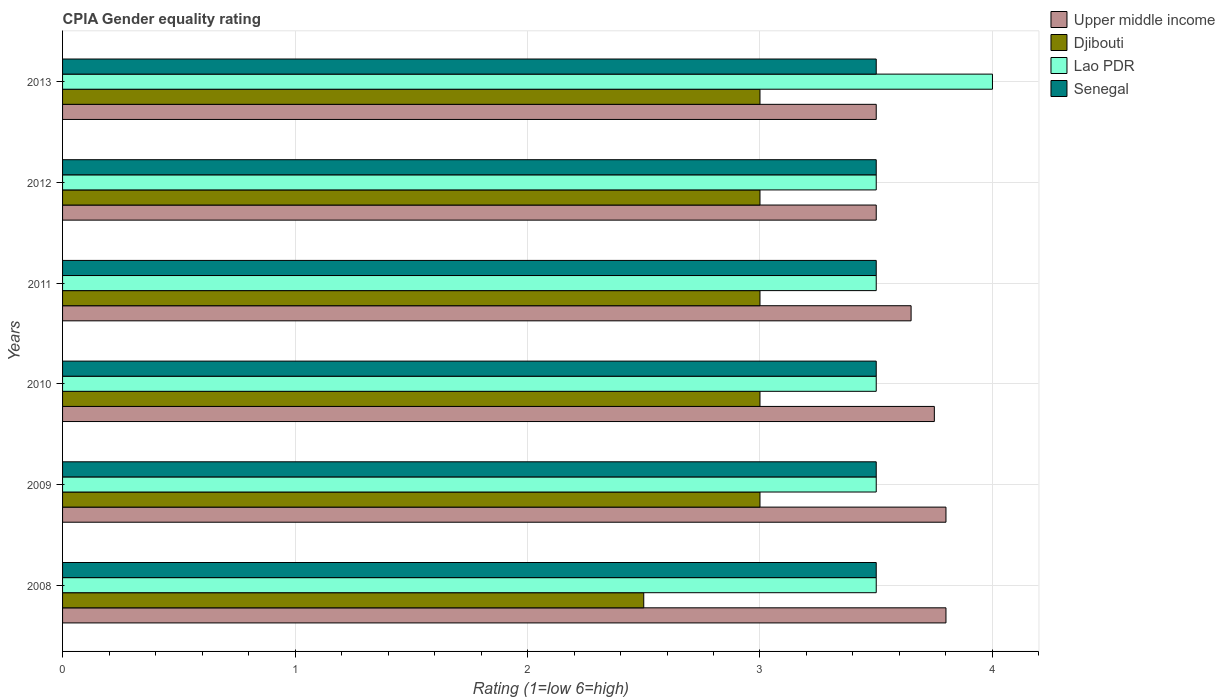How many different coloured bars are there?
Give a very brief answer. 4. Are the number of bars on each tick of the Y-axis equal?
Keep it short and to the point. Yes. How many bars are there on the 1st tick from the bottom?
Ensure brevity in your answer.  4. What is the label of the 1st group of bars from the top?
Give a very brief answer. 2013. In how many cases, is the number of bars for a given year not equal to the number of legend labels?
Offer a very short reply. 0. Across all years, what is the minimum CPIA rating in Lao PDR?
Provide a short and direct response. 3.5. In which year was the CPIA rating in Djibouti minimum?
Your answer should be very brief. 2008. What is the total CPIA rating in Djibouti in the graph?
Keep it short and to the point. 17.5. What is the difference between the CPIA rating in Upper middle income in 2011 and the CPIA rating in Senegal in 2008?
Keep it short and to the point. 0.15. What is the average CPIA rating in Djibouti per year?
Give a very brief answer. 2.92. What is the ratio of the CPIA rating in Upper middle income in 2008 to that in 2012?
Ensure brevity in your answer.  1.09. What is the difference between the highest and the lowest CPIA rating in Djibouti?
Your answer should be compact. 0.5. Is it the case that in every year, the sum of the CPIA rating in Senegal and CPIA rating in Lao PDR is greater than the sum of CPIA rating in Upper middle income and CPIA rating in Djibouti?
Your answer should be compact. No. What does the 2nd bar from the top in 2009 represents?
Provide a succinct answer. Lao PDR. What does the 4th bar from the bottom in 2013 represents?
Provide a short and direct response. Senegal. Is it the case that in every year, the sum of the CPIA rating in Senegal and CPIA rating in Djibouti is greater than the CPIA rating in Upper middle income?
Keep it short and to the point. Yes. How many bars are there?
Ensure brevity in your answer.  24. How many years are there in the graph?
Provide a succinct answer. 6. What is the title of the graph?
Give a very brief answer. CPIA Gender equality rating. What is the label or title of the X-axis?
Offer a very short reply. Rating (1=low 6=high). What is the Rating (1=low 6=high) of Upper middle income in 2008?
Ensure brevity in your answer.  3.8. What is the Rating (1=low 6=high) of Djibouti in 2008?
Ensure brevity in your answer.  2.5. What is the Rating (1=low 6=high) of Lao PDR in 2008?
Offer a terse response. 3.5. What is the Rating (1=low 6=high) in Senegal in 2008?
Your answer should be compact. 3.5. What is the Rating (1=low 6=high) in Upper middle income in 2009?
Offer a terse response. 3.8. What is the Rating (1=low 6=high) in Lao PDR in 2009?
Provide a succinct answer. 3.5. What is the Rating (1=low 6=high) of Upper middle income in 2010?
Give a very brief answer. 3.75. What is the Rating (1=low 6=high) in Upper middle income in 2011?
Provide a succinct answer. 3.65. What is the Rating (1=low 6=high) in Djibouti in 2011?
Give a very brief answer. 3. What is the Rating (1=low 6=high) in Lao PDR in 2011?
Provide a short and direct response. 3.5. What is the Rating (1=low 6=high) of Lao PDR in 2012?
Make the answer very short. 3.5. What is the Rating (1=low 6=high) of Upper middle income in 2013?
Give a very brief answer. 3.5. What is the Rating (1=low 6=high) in Lao PDR in 2013?
Offer a very short reply. 4. Across all years, what is the maximum Rating (1=low 6=high) of Lao PDR?
Provide a succinct answer. 4. Across all years, what is the maximum Rating (1=low 6=high) of Senegal?
Your answer should be very brief. 3.5. Across all years, what is the minimum Rating (1=low 6=high) of Upper middle income?
Your answer should be very brief. 3.5. Across all years, what is the minimum Rating (1=low 6=high) in Lao PDR?
Your answer should be very brief. 3.5. Across all years, what is the minimum Rating (1=low 6=high) in Senegal?
Provide a succinct answer. 3.5. What is the total Rating (1=low 6=high) of Upper middle income in the graph?
Provide a succinct answer. 22. What is the total Rating (1=low 6=high) of Djibouti in the graph?
Ensure brevity in your answer.  17.5. What is the total Rating (1=low 6=high) in Senegal in the graph?
Ensure brevity in your answer.  21. What is the difference between the Rating (1=low 6=high) in Upper middle income in 2008 and that in 2009?
Give a very brief answer. 0. What is the difference between the Rating (1=low 6=high) of Djibouti in 2008 and that in 2009?
Offer a terse response. -0.5. What is the difference between the Rating (1=low 6=high) in Lao PDR in 2008 and that in 2009?
Give a very brief answer. 0. What is the difference between the Rating (1=low 6=high) in Senegal in 2008 and that in 2009?
Your answer should be very brief. 0. What is the difference between the Rating (1=low 6=high) of Upper middle income in 2008 and that in 2010?
Offer a very short reply. 0.05. What is the difference between the Rating (1=low 6=high) of Senegal in 2008 and that in 2010?
Your response must be concise. 0. What is the difference between the Rating (1=low 6=high) in Djibouti in 2008 and that in 2011?
Ensure brevity in your answer.  -0.5. What is the difference between the Rating (1=low 6=high) of Upper middle income in 2008 and that in 2012?
Provide a short and direct response. 0.3. What is the difference between the Rating (1=low 6=high) in Lao PDR in 2008 and that in 2012?
Offer a terse response. 0. What is the difference between the Rating (1=low 6=high) of Upper middle income in 2008 and that in 2013?
Give a very brief answer. 0.3. What is the difference between the Rating (1=low 6=high) in Djibouti in 2008 and that in 2013?
Your response must be concise. -0.5. What is the difference between the Rating (1=low 6=high) of Lao PDR in 2008 and that in 2013?
Keep it short and to the point. -0.5. What is the difference between the Rating (1=low 6=high) of Senegal in 2008 and that in 2013?
Your answer should be very brief. 0. What is the difference between the Rating (1=low 6=high) in Lao PDR in 2009 and that in 2010?
Make the answer very short. 0. What is the difference between the Rating (1=low 6=high) of Lao PDR in 2009 and that in 2011?
Offer a terse response. 0. What is the difference between the Rating (1=low 6=high) of Senegal in 2009 and that in 2011?
Your answer should be very brief. 0. What is the difference between the Rating (1=low 6=high) in Upper middle income in 2009 and that in 2012?
Provide a short and direct response. 0.3. What is the difference between the Rating (1=low 6=high) in Lao PDR in 2009 and that in 2012?
Your answer should be compact. 0. What is the difference between the Rating (1=low 6=high) in Upper middle income in 2009 and that in 2013?
Your answer should be compact. 0.3. What is the difference between the Rating (1=low 6=high) of Djibouti in 2009 and that in 2013?
Make the answer very short. 0. What is the difference between the Rating (1=low 6=high) in Senegal in 2009 and that in 2013?
Provide a succinct answer. 0. What is the difference between the Rating (1=low 6=high) of Upper middle income in 2010 and that in 2011?
Provide a short and direct response. 0.1. What is the difference between the Rating (1=low 6=high) of Djibouti in 2010 and that in 2012?
Offer a terse response. 0. What is the difference between the Rating (1=low 6=high) in Lao PDR in 2010 and that in 2012?
Provide a succinct answer. 0. What is the difference between the Rating (1=low 6=high) in Lao PDR in 2010 and that in 2013?
Provide a short and direct response. -0.5. What is the difference between the Rating (1=low 6=high) of Upper middle income in 2011 and that in 2012?
Provide a succinct answer. 0.15. What is the difference between the Rating (1=low 6=high) of Lao PDR in 2011 and that in 2012?
Ensure brevity in your answer.  0. What is the difference between the Rating (1=low 6=high) of Senegal in 2011 and that in 2012?
Provide a short and direct response. 0. What is the difference between the Rating (1=low 6=high) of Upper middle income in 2011 and that in 2013?
Provide a succinct answer. 0.15. What is the difference between the Rating (1=low 6=high) in Lao PDR in 2012 and that in 2013?
Give a very brief answer. -0.5. What is the difference between the Rating (1=low 6=high) in Upper middle income in 2008 and the Rating (1=low 6=high) in Lao PDR in 2009?
Offer a very short reply. 0.3. What is the difference between the Rating (1=low 6=high) of Djibouti in 2008 and the Rating (1=low 6=high) of Lao PDR in 2009?
Provide a succinct answer. -1. What is the difference between the Rating (1=low 6=high) of Upper middle income in 2008 and the Rating (1=low 6=high) of Djibouti in 2010?
Provide a succinct answer. 0.8. What is the difference between the Rating (1=low 6=high) of Djibouti in 2008 and the Rating (1=low 6=high) of Lao PDR in 2010?
Offer a terse response. -1. What is the difference between the Rating (1=low 6=high) in Djibouti in 2008 and the Rating (1=low 6=high) in Senegal in 2010?
Your answer should be very brief. -1. What is the difference between the Rating (1=low 6=high) in Upper middle income in 2008 and the Rating (1=low 6=high) in Djibouti in 2011?
Provide a short and direct response. 0.8. What is the difference between the Rating (1=low 6=high) of Upper middle income in 2008 and the Rating (1=low 6=high) of Lao PDR in 2011?
Your answer should be compact. 0.3. What is the difference between the Rating (1=low 6=high) of Upper middle income in 2008 and the Rating (1=low 6=high) of Senegal in 2011?
Ensure brevity in your answer.  0.3. What is the difference between the Rating (1=low 6=high) of Lao PDR in 2008 and the Rating (1=low 6=high) of Senegal in 2011?
Give a very brief answer. 0. What is the difference between the Rating (1=low 6=high) in Upper middle income in 2008 and the Rating (1=low 6=high) in Senegal in 2012?
Provide a short and direct response. 0.3. What is the difference between the Rating (1=low 6=high) in Djibouti in 2008 and the Rating (1=low 6=high) in Senegal in 2012?
Your answer should be compact. -1. What is the difference between the Rating (1=low 6=high) of Upper middle income in 2008 and the Rating (1=low 6=high) of Djibouti in 2013?
Ensure brevity in your answer.  0.8. What is the difference between the Rating (1=low 6=high) in Upper middle income in 2009 and the Rating (1=low 6=high) in Lao PDR in 2010?
Your response must be concise. 0.3. What is the difference between the Rating (1=low 6=high) of Djibouti in 2009 and the Rating (1=low 6=high) of Lao PDR in 2010?
Make the answer very short. -0.5. What is the difference between the Rating (1=low 6=high) in Lao PDR in 2009 and the Rating (1=low 6=high) in Senegal in 2010?
Your answer should be compact. 0. What is the difference between the Rating (1=low 6=high) of Upper middle income in 2009 and the Rating (1=low 6=high) of Senegal in 2011?
Give a very brief answer. 0.3. What is the difference between the Rating (1=low 6=high) in Djibouti in 2009 and the Rating (1=low 6=high) in Senegal in 2011?
Your answer should be very brief. -0.5. What is the difference between the Rating (1=low 6=high) of Djibouti in 2009 and the Rating (1=low 6=high) of Lao PDR in 2012?
Provide a short and direct response. -0.5. What is the difference between the Rating (1=low 6=high) in Upper middle income in 2009 and the Rating (1=low 6=high) in Djibouti in 2013?
Your response must be concise. 0.8. What is the difference between the Rating (1=low 6=high) in Upper middle income in 2009 and the Rating (1=low 6=high) in Senegal in 2013?
Your response must be concise. 0.3. What is the difference between the Rating (1=low 6=high) of Djibouti in 2009 and the Rating (1=low 6=high) of Lao PDR in 2013?
Your response must be concise. -1. What is the difference between the Rating (1=low 6=high) in Upper middle income in 2010 and the Rating (1=low 6=high) in Senegal in 2011?
Give a very brief answer. 0.25. What is the difference between the Rating (1=low 6=high) of Djibouti in 2010 and the Rating (1=low 6=high) of Lao PDR in 2011?
Your response must be concise. -0.5. What is the difference between the Rating (1=low 6=high) in Djibouti in 2010 and the Rating (1=low 6=high) in Senegal in 2011?
Offer a terse response. -0.5. What is the difference between the Rating (1=low 6=high) of Lao PDR in 2010 and the Rating (1=low 6=high) of Senegal in 2011?
Provide a short and direct response. 0. What is the difference between the Rating (1=low 6=high) of Upper middle income in 2010 and the Rating (1=low 6=high) of Djibouti in 2012?
Offer a terse response. 0.75. What is the difference between the Rating (1=low 6=high) in Upper middle income in 2010 and the Rating (1=low 6=high) in Lao PDR in 2012?
Provide a succinct answer. 0.25. What is the difference between the Rating (1=low 6=high) in Upper middle income in 2010 and the Rating (1=low 6=high) in Senegal in 2012?
Offer a very short reply. 0.25. What is the difference between the Rating (1=low 6=high) of Djibouti in 2010 and the Rating (1=low 6=high) of Lao PDR in 2012?
Your response must be concise. -0.5. What is the difference between the Rating (1=low 6=high) of Lao PDR in 2010 and the Rating (1=low 6=high) of Senegal in 2012?
Provide a succinct answer. 0. What is the difference between the Rating (1=low 6=high) of Upper middle income in 2010 and the Rating (1=low 6=high) of Lao PDR in 2013?
Make the answer very short. -0.25. What is the difference between the Rating (1=low 6=high) of Upper middle income in 2010 and the Rating (1=low 6=high) of Senegal in 2013?
Give a very brief answer. 0.25. What is the difference between the Rating (1=low 6=high) of Djibouti in 2010 and the Rating (1=low 6=high) of Senegal in 2013?
Give a very brief answer. -0.5. What is the difference between the Rating (1=low 6=high) of Lao PDR in 2010 and the Rating (1=low 6=high) of Senegal in 2013?
Your answer should be very brief. 0. What is the difference between the Rating (1=low 6=high) of Upper middle income in 2011 and the Rating (1=low 6=high) of Djibouti in 2012?
Give a very brief answer. 0.65. What is the difference between the Rating (1=low 6=high) of Upper middle income in 2011 and the Rating (1=low 6=high) of Lao PDR in 2012?
Your answer should be compact. 0.15. What is the difference between the Rating (1=low 6=high) in Djibouti in 2011 and the Rating (1=low 6=high) in Lao PDR in 2012?
Make the answer very short. -0.5. What is the difference between the Rating (1=low 6=high) of Upper middle income in 2011 and the Rating (1=low 6=high) of Djibouti in 2013?
Provide a short and direct response. 0.65. What is the difference between the Rating (1=low 6=high) of Upper middle income in 2011 and the Rating (1=low 6=high) of Lao PDR in 2013?
Your response must be concise. -0.35. What is the difference between the Rating (1=low 6=high) of Djibouti in 2011 and the Rating (1=low 6=high) of Lao PDR in 2013?
Offer a very short reply. -1. What is the difference between the Rating (1=low 6=high) of Upper middle income in 2012 and the Rating (1=low 6=high) of Djibouti in 2013?
Your answer should be compact. 0.5. What is the difference between the Rating (1=low 6=high) in Upper middle income in 2012 and the Rating (1=low 6=high) in Lao PDR in 2013?
Your response must be concise. -0.5. What is the difference between the Rating (1=low 6=high) in Djibouti in 2012 and the Rating (1=low 6=high) in Lao PDR in 2013?
Offer a terse response. -1. What is the difference between the Rating (1=low 6=high) of Djibouti in 2012 and the Rating (1=low 6=high) of Senegal in 2013?
Your answer should be compact. -0.5. What is the average Rating (1=low 6=high) of Upper middle income per year?
Your response must be concise. 3.67. What is the average Rating (1=low 6=high) of Djibouti per year?
Make the answer very short. 2.92. What is the average Rating (1=low 6=high) in Lao PDR per year?
Provide a succinct answer. 3.58. In the year 2008, what is the difference between the Rating (1=low 6=high) in Upper middle income and Rating (1=low 6=high) in Lao PDR?
Make the answer very short. 0.3. In the year 2008, what is the difference between the Rating (1=low 6=high) in Djibouti and Rating (1=low 6=high) in Senegal?
Give a very brief answer. -1. In the year 2009, what is the difference between the Rating (1=low 6=high) of Upper middle income and Rating (1=low 6=high) of Djibouti?
Make the answer very short. 0.8. In the year 2009, what is the difference between the Rating (1=low 6=high) of Upper middle income and Rating (1=low 6=high) of Lao PDR?
Keep it short and to the point. 0.3. In the year 2009, what is the difference between the Rating (1=low 6=high) in Djibouti and Rating (1=low 6=high) in Lao PDR?
Give a very brief answer. -0.5. In the year 2009, what is the difference between the Rating (1=low 6=high) in Djibouti and Rating (1=low 6=high) in Senegal?
Your response must be concise. -0.5. In the year 2010, what is the difference between the Rating (1=low 6=high) in Upper middle income and Rating (1=low 6=high) in Djibouti?
Offer a terse response. 0.75. In the year 2010, what is the difference between the Rating (1=low 6=high) in Lao PDR and Rating (1=low 6=high) in Senegal?
Make the answer very short. 0. In the year 2011, what is the difference between the Rating (1=low 6=high) of Upper middle income and Rating (1=low 6=high) of Djibouti?
Make the answer very short. 0.65. In the year 2011, what is the difference between the Rating (1=low 6=high) in Upper middle income and Rating (1=low 6=high) in Lao PDR?
Make the answer very short. 0.15. In the year 2011, what is the difference between the Rating (1=low 6=high) in Djibouti and Rating (1=low 6=high) in Lao PDR?
Ensure brevity in your answer.  -0.5. In the year 2011, what is the difference between the Rating (1=low 6=high) of Djibouti and Rating (1=low 6=high) of Senegal?
Your response must be concise. -0.5. In the year 2011, what is the difference between the Rating (1=low 6=high) in Lao PDR and Rating (1=low 6=high) in Senegal?
Your response must be concise. 0. In the year 2012, what is the difference between the Rating (1=low 6=high) of Upper middle income and Rating (1=low 6=high) of Lao PDR?
Provide a succinct answer. 0. In the year 2013, what is the difference between the Rating (1=low 6=high) in Upper middle income and Rating (1=low 6=high) in Djibouti?
Your answer should be compact. 0.5. In the year 2013, what is the difference between the Rating (1=low 6=high) in Upper middle income and Rating (1=low 6=high) in Lao PDR?
Your response must be concise. -0.5. In the year 2013, what is the difference between the Rating (1=low 6=high) in Djibouti and Rating (1=low 6=high) in Lao PDR?
Provide a short and direct response. -1. In the year 2013, what is the difference between the Rating (1=low 6=high) of Djibouti and Rating (1=low 6=high) of Senegal?
Offer a very short reply. -0.5. In the year 2013, what is the difference between the Rating (1=low 6=high) of Lao PDR and Rating (1=low 6=high) of Senegal?
Provide a short and direct response. 0.5. What is the ratio of the Rating (1=low 6=high) in Djibouti in 2008 to that in 2009?
Your response must be concise. 0.83. What is the ratio of the Rating (1=low 6=high) in Lao PDR in 2008 to that in 2009?
Make the answer very short. 1. What is the ratio of the Rating (1=low 6=high) of Senegal in 2008 to that in 2009?
Provide a succinct answer. 1. What is the ratio of the Rating (1=low 6=high) in Upper middle income in 2008 to that in 2010?
Provide a succinct answer. 1.01. What is the ratio of the Rating (1=low 6=high) in Lao PDR in 2008 to that in 2010?
Give a very brief answer. 1. What is the ratio of the Rating (1=low 6=high) of Senegal in 2008 to that in 2010?
Give a very brief answer. 1. What is the ratio of the Rating (1=low 6=high) in Upper middle income in 2008 to that in 2011?
Your response must be concise. 1.04. What is the ratio of the Rating (1=low 6=high) in Upper middle income in 2008 to that in 2012?
Your response must be concise. 1.09. What is the ratio of the Rating (1=low 6=high) of Djibouti in 2008 to that in 2012?
Your response must be concise. 0.83. What is the ratio of the Rating (1=low 6=high) of Senegal in 2008 to that in 2012?
Provide a succinct answer. 1. What is the ratio of the Rating (1=low 6=high) in Upper middle income in 2008 to that in 2013?
Offer a very short reply. 1.09. What is the ratio of the Rating (1=low 6=high) of Djibouti in 2008 to that in 2013?
Keep it short and to the point. 0.83. What is the ratio of the Rating (1=low 6=high) in Upper middle income in 2009 to that in 2010?
Make the answer very short. 1.01. What is the ratio of the Rating (1=low 6=high) of Djibouti in 2009 to that in 2010?
Give a very brief answer. 1. What is the ratio of the Rating (1=low 6=high) of Senegal in 2009 to that in 2010?
Ensure brevity in your answer.  1. What is the ratio of the Rating (1=low 6=high) in Upper middle income in 2009 to that in 2011?
Provide a succinct answer. 1.04. What is the ratio of the Rating (1=low 6=high) of Senegal in 2009 to that in 2011?
Make the answer very short. 1. What is the ratio of the Rating (1=low 6=high) in Upper middle income in 2009 to that in 2012?
Keep it short and to the point. 1.09. What is the ratio of the Rating (1=low 6=high) in Lao PDR in 2009 to that in 2012?
Provide a succinct answer. 1. What is the ratio of the Rating (1=low 6=high) of Upper middle income in 2009 to that in 2013?
Make the answer very short. 1.09. What is the ratio of the Rating (1=low 6=high) of Lao PDR in 2009 to that in 2013?
Provide a short and direct response. 0.88. What is the ratio of the Rating (1=low 6=high) in Upper middle income in 2010 to that in 2011?
Offer a terse response. 1.03. What is the ratio of the Rating (1=low 6=high) in Djibouti in 2010 to that in 2011?
Your answer should be very brief. 1. What is the ratio of the Rating (1=low 6=high) of Senegal in 2010 to that in 2011?
Your answer should be very brief. 1. What is the ratio of the Rating (1=low 6=high) of Upper middle income in 2010 to that in 2012?
Ensure brevity in your answer.  1.07. What is the ratio of the Rating (1=low 6=high) in Lao PDR in 2010 to that in 2012?
Your response must be concise. 1. What is the ratio of the Rating (1=low 6=high) in Senegal in 2010 to that in 2012?
Your answer should be compact. 1. What is the ratio of the Rating (1=low 6=high) in Upper middle income in 2010 to that in 2013?
Your response must be concise. 1.07. What is the ratio of the Rating (1=low 6=high) in Djibouti in 2010 to that in 2013?
Your answer should be compact. 1. What is the ratio of the Rating (1=low 6=high) in Lao PDR in 2010 to that in 2013?
Make the answer very short. 0.88. What is the ratio of the Rating (1=low 6=high) of Upper middle income in 2011 to that in 2012?
Keep it short and to the point. 1.04. What is the ratio of the Rating (1=low 6=high) in Upper middle income in 2011 to that in 2013?
Provide a succinct answer. 1.04. What is the ratio of the Rating (1=low 6=high) in Senegal in 2011 to that in 2013?
Your answer should be compact. 1. What is the ratio of the Rating (1=low 6=high) in Upper middle income in 2012 to that in 2013?
Make the answer very short. 1. What is the ratio of the Rating (1=low 6=high) of Djibouti in 2012 to that in 2013?
Provide a succinct answer. 1. What is the ratio of the Rating (1=low 6=high) in Lao PDR in 2012 to that in 2013?
Your answer should be compact. 0.88. What is the ratio of the Rating (1=low 6=high) in Senegal in 2012 to that in 2013?
Offer a terse response. 1. What is the difference between the highest and the lowest Rating (1=low 6=high) of Djibouti?
Provide a short and direct response. 0.5. What is the difference between the highest and the lowest Rating (1=low 6=high) in Lao PDR?
Give a very brief answer. 0.5. What is the difference between the highest and the lowest Rating (1=low 6=high) of Senegal?
Offer a very short reply. 0. 